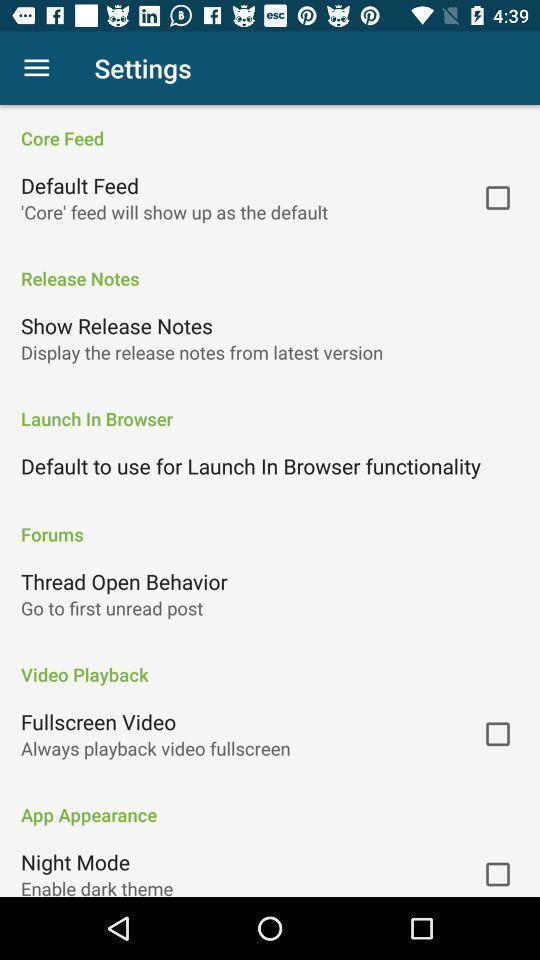Describe the visual elements of this screenshot. Screen displaying the settings page. 